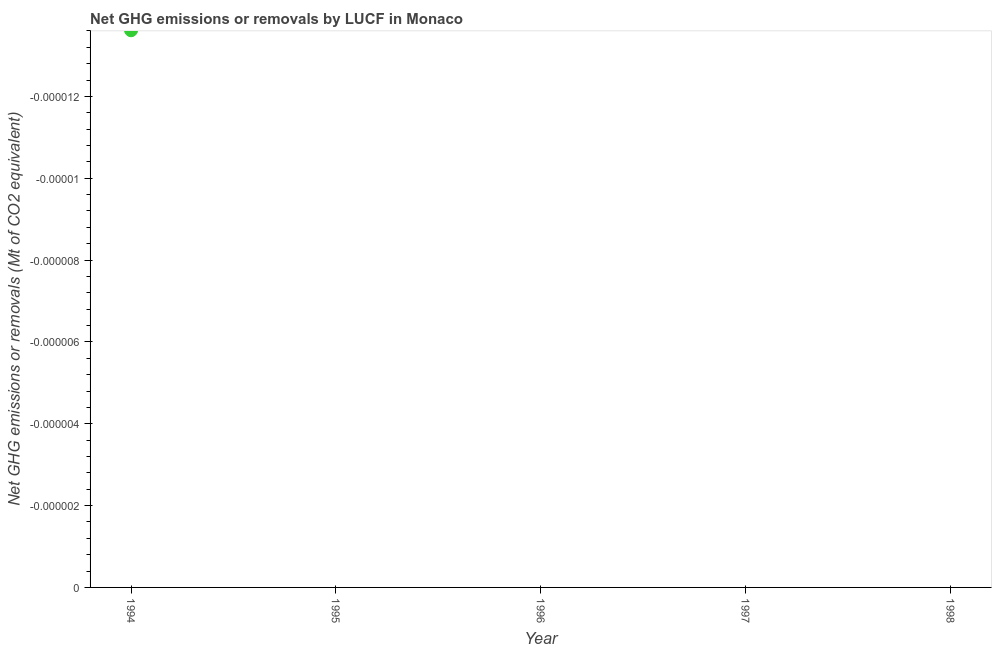Across all years, what is the minimum ghg net emissions or removals?
Give a very brief answer. 0. What is the average ghg net emissions or removals per year?
Keep it short and to the point. 0. What is the median ghg net emissions or removals?
Provide a short and direct response. 0. In how many years, is the ghg net emissions or removals greater than -4e-07 Mt?
Your response must be concise. 0. In how many years, is the ghg net emissions or removals greater than the average ghg net emissions or removals taken over all years?
Offer a terse response. 0. How many years are there in the graph?
Keep it short and to the point. 5. What is the difference between two consecutive major ticks on the Y-axis?
Provide a succinct answer. 1.9999999999999995e-6. Does the graph contain any zero values?
Offer a terse response. Yes. Does the graph contain grids?
Your answer should be compact. No. What is the title of the graph?
Keep it short and to the point. Net GHG emissions or removals by LUCF in Monaco. What is the label or title of the X-axis?
Ensure brevity in your answer.  Year. What is the label or title of the Y-axis?
Keep it short and to the point. Net GHG emissions or removals (Mt of CO2 equivalent). What is the Net GHG emissions or removals (Mt of CO2 equivalent) in 1994?
Give a very brief answer. 0. What is the Net GHG emissions or removals (Mt of CO2 equivalent) in 1995?
Your answer should be very brief. 0. What is the Net GHG emissions or removals (Mt of CO2 equivalent) in 1997?
Provide a succinct answer. 0. 